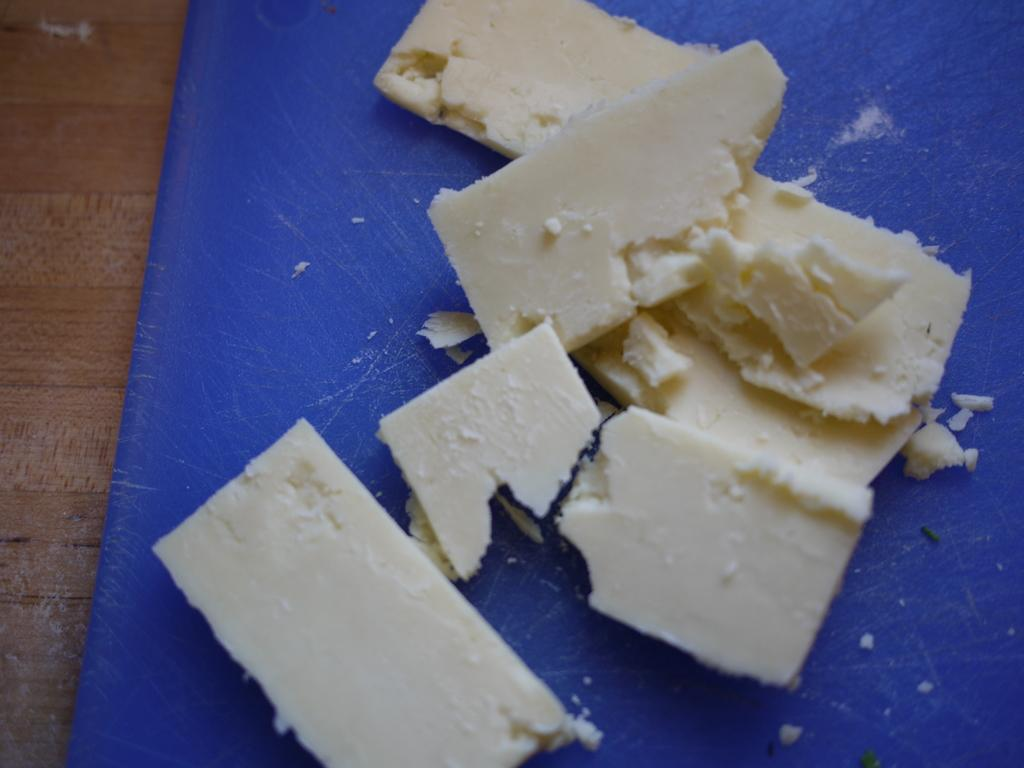What type of items can be seen in the image? There are food items in the image. On what is the food placed? The food items are on a blue object. What is the blue object placed on? The blue object is visible on a wooden surface. Can you tell me how many dogs are visible in the image? There are no dogs present in the image. What type of change is being used to pay for the food in the image? There is no indication of payment or change in the image. 